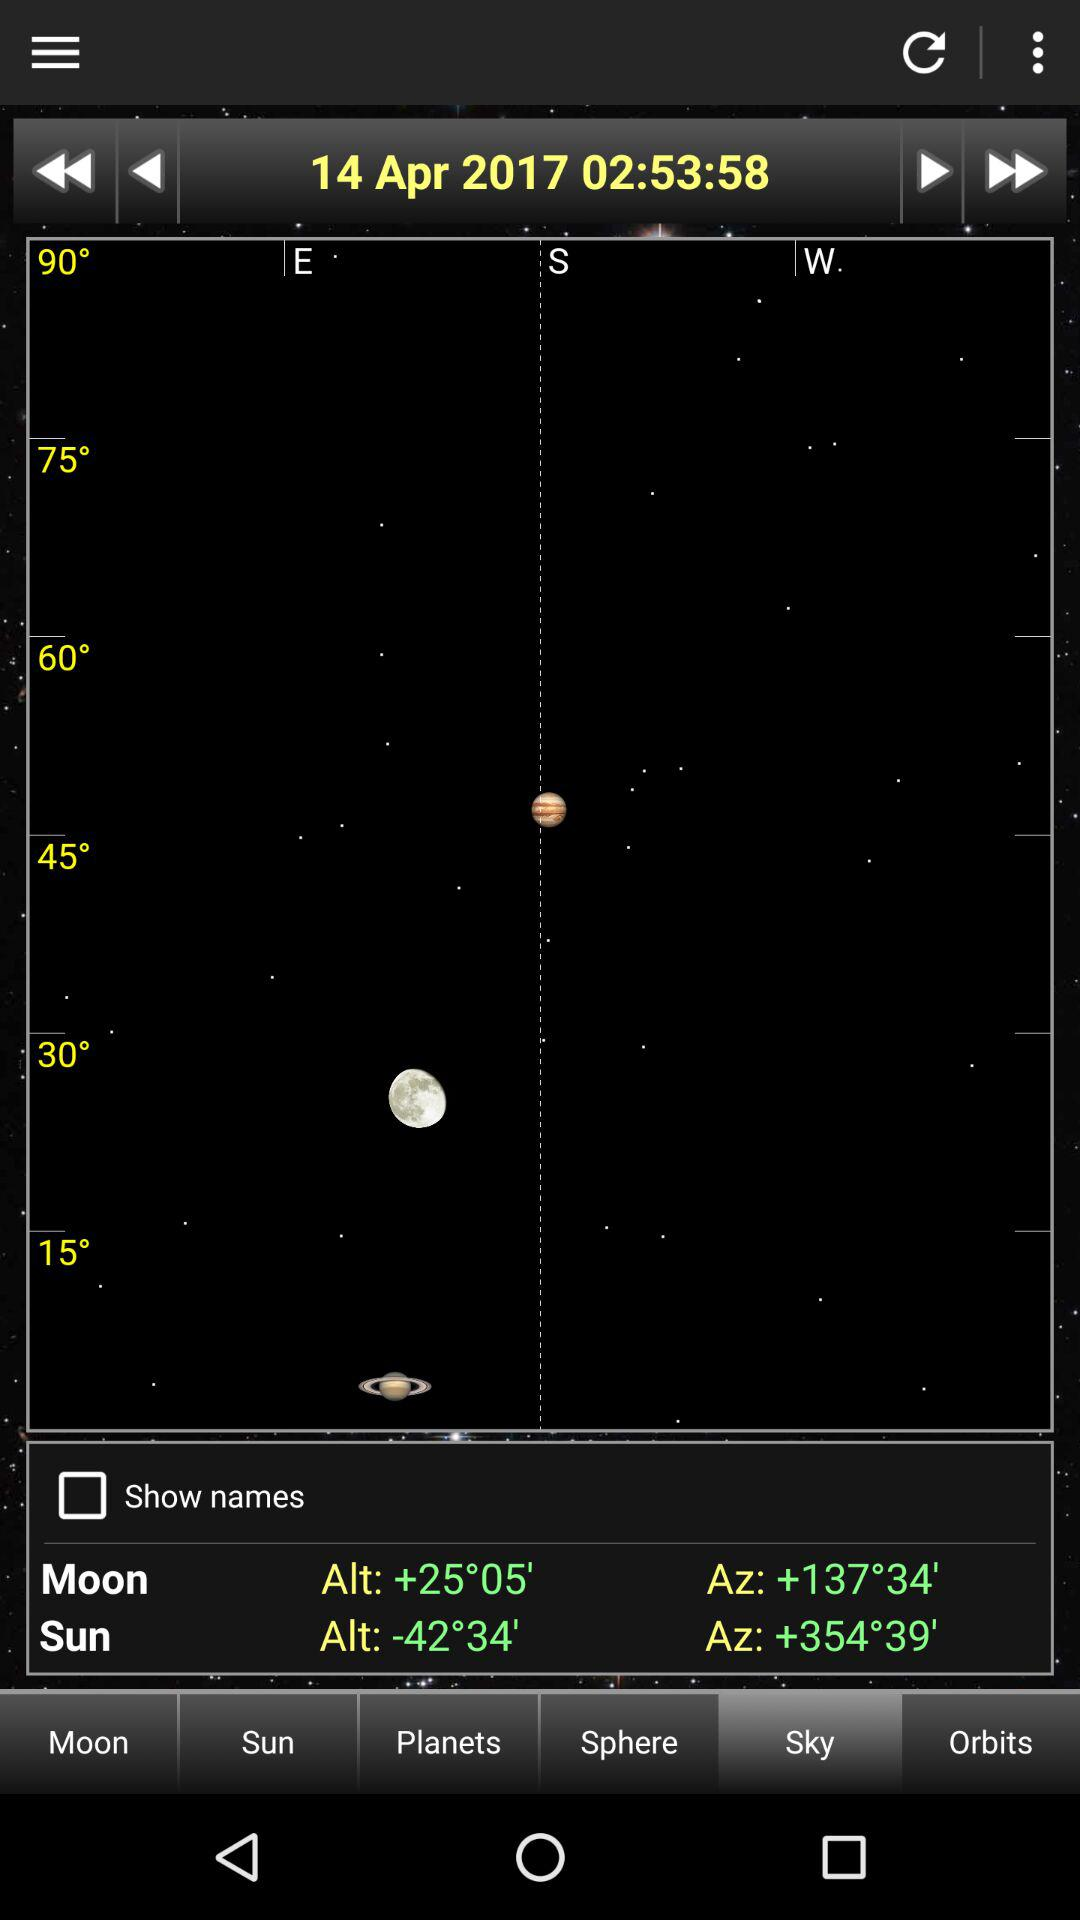What is the date of observation? The date of observation is April 14, 2017. 